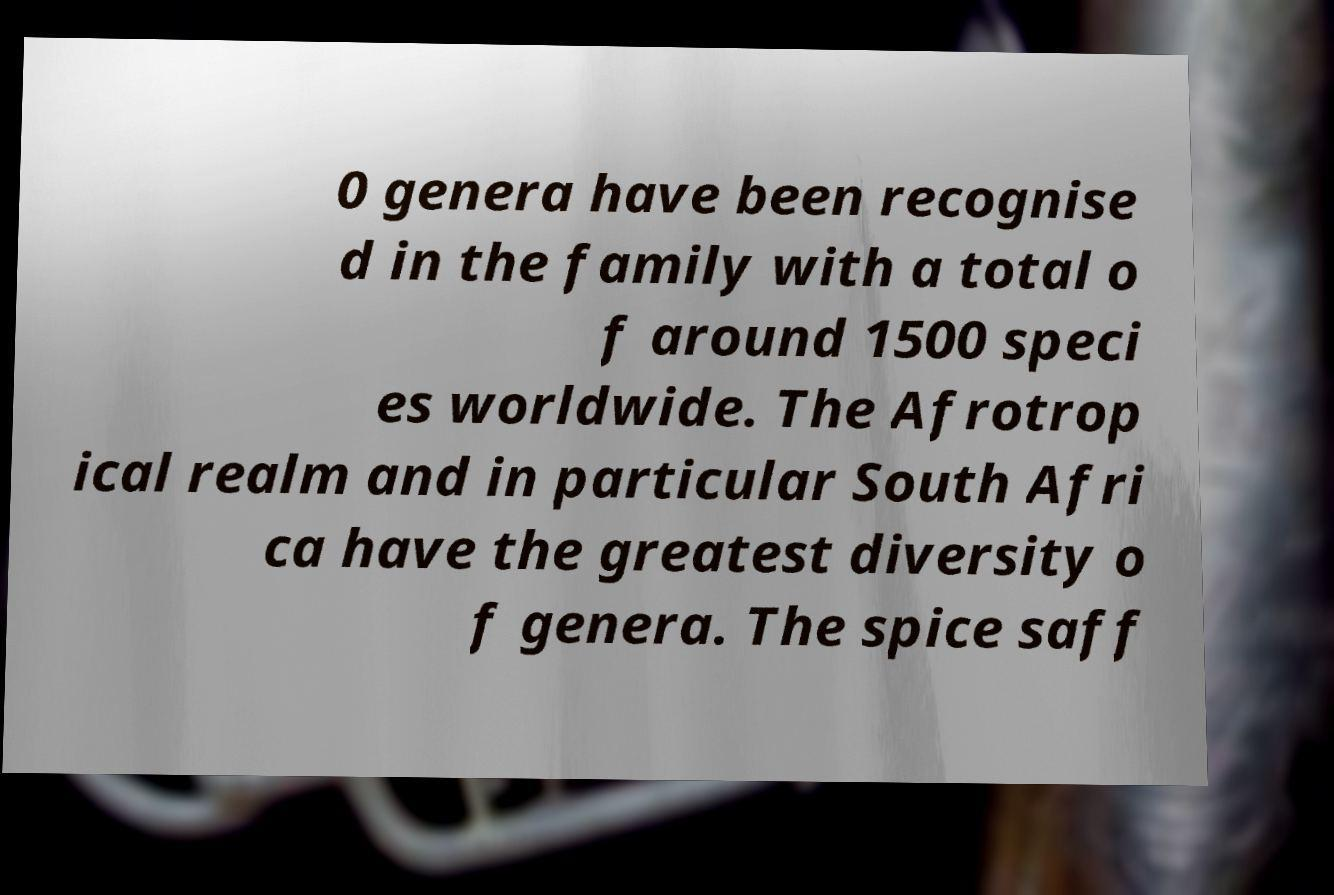Please read and relay the text visible in this image. What does it say? 0 genera have been recognise d in the family with a total o f around 1500 speci es worldwide. The Afrotrop ical realm and in particular South Afri ca have the greatest diversity o f genera. The spice saff 